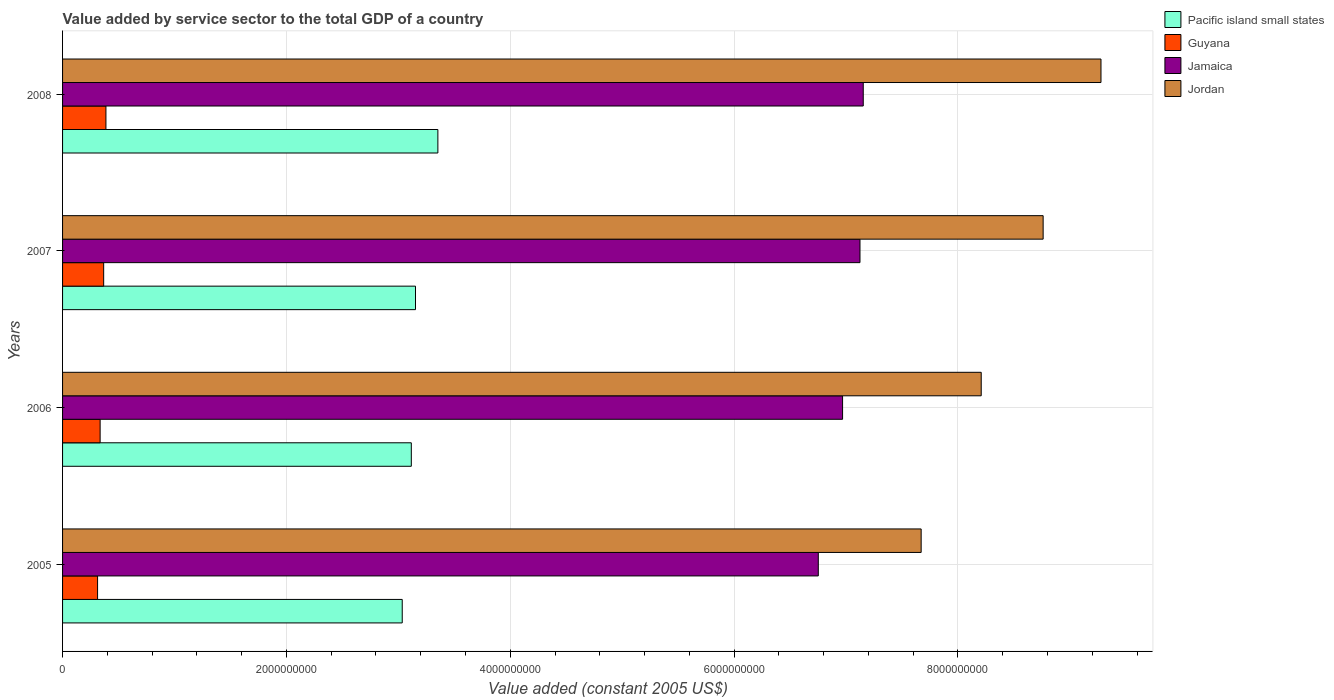How many different coloured bars are there?
Your answer should be compact. 4. How many bars are there on the 2nd tick from the top?
Ensure brevity in your answer.  4. What is the value added by service sector in Guyana in 2005?
Offer a very short reply. 3.13e+08. Across all years, what is the maximum value added by service sector in Jamaica?
Give a very brief answer. 7.15e+09. Across all years, what is the minimum value added by service sector in Pacific island small states?
Keep it short and to the point. 3.03e+09. What is the total value added by service sector in Pacific island small states in the graph?
Provide a succinct answer. 1.27e+1. What is the difference between the value added by service sector in Jamaica in 2006 and that in 2007?
Offer a very short reply. -1.55e+08. What is the difference between the value added by service sector in Jamaica in 2008 and the value added by service sector in Guyana in 2007?
Offer a very short reply. 6.79e+09. What is the average value added by service sector in Jamaica per year?
Your answer should be compact. 7.00e+09. In the year 2007, what is the difference between the value added by service sector in Jordan and value added by service sector in Jamaica?
Provide a succinct answer. 1.64e+09. What is the ratio of the value added by service sector in Pacific island small states in 2007 to that in 2008?
Your response must be concise. 0.94. What is the difference between the highest and the second highest value added by service sector in Jamaica?
Offer a terse response. 2.92e+07. What is the difference between the highest and the lowest value added by service sector in Jamaica?
Your answer should be very brief. 4.02e+08. What does the 1st bar from the top in 2007 represents?
Your answer should be compact. Jordan. What does the 2nd bar from the bottom in 2005 represents?
Make the answer very short. Guyana. How many bars are there?
Offer a very short reply. 16. How many years are there in the graph?
Provide a succinct answer. 4. Does the graph contain any zero values?
Make the answer very short. No. How many legend labels are there?
Ensure brevity in your answer.  4. How are the legend labels stacked?
Your answer should be compact. Vertical. What is the title of the graph?
Provide a short and direct response. Value added by service sector to the total GDP of a country. Does "Greece" appear as one of the legend labels in the graph?
Provide a short and direct response. No. What is the label or title of the X-axis?
Your answer should be compact. Value added (constant 2005 US$). What is the label or title of the Y-axis?
Ensure brevity in your answer.  Years. What is the Value added (constant 2005 US$) of Pacific island small states in 2005?
Make the answer very short. 3.03e+09. What is the Value added (constant 2005 US$) of Guyana in 2005?
Offer a very short reply. 3.13e+08. What is the Value added (constant 2005 US$) of Jamaica in 2005?
Provide a short and direct response. 6.75e+09. What is the Value added (constant 2005 US$) of Jordan in 2005?
Make the answer very short. 7.67e+09. What is the Value added (constant 2005 US$) of Pacific island small states in 2006?
Offer a very short reply. 3.12e+09. What is the Value added (constant 2005 US$) of Guyana in 2006?
Make the answer very short. 3.36e+08. What is the Value added (constant 2005 US$) of Jamaica in 2006?
Your answer should be very brief. 6.97e+09. What is the Value added (constant 2005 US$) in Jordan in 2006?
Offer a terse response. 8.21e+09. What is the Value added (constant 2005 US$) in Pacific island small states in 2007?
Ensure brevity in your answer.  3.15e+09. What is the Value added (constant 2005 US$) of Guyana in 2007?
Offer a terse response. 3.67e+08. What is the Value added (constant 2005 US$) in Jamaica in 2007?
Offer a terse response. 7.12e+09. What is the Value added (constant 2005 US$) in Jordan in 2007?
Your response must be concise. 8.76e+09. What is the Value added (constant 2005 US$) in Pacific island small states in 2008?
Provide a short and direct response. 3.35e+09. What is the Value added (constant 2005 US$) in Guyana in 2008?
Provide a short and direct response. 3.87e+08. What is the Value added (constant 2005 US$) in Jamaica in 2008?
Offer a very short reply. 7.15e+09. What is the Value added (constant 2005 US$) of Jordan in 2008?
Offer a very short reply. 9.28e+09. Across all years, what is the maximum Value added (constant 2005 US$) in Pacific island small states?
Your answer should be compact. 3.35e+09. Across all years, what is the maximum Value added (constant 2005 US$) of Guyana?
Ensure brevity in your answer.  3.87e+08. Across all years, what is the maximum Value added (constant 2005 US$) in Jamaica?
Offer a very short reply. 7.15e+09. Across all years, what is the maximum Value added (constant 2005 US$) of Jordan?
Make the answer very short. 9.28e+09. Across all years, what is the minimum Value added (constant 2005 US$) of Pacific island small states?
Your answer should be compact. 3.03e+09. Across all years, what is the minimum Value added (constant 2005 US$) of Guyana?
Provide a short and direct response. 3.13e+08. Across all years, what is the minimum Value added (constant 2005 US$) in Jamaica?
Offer a very short reply. 6.75e+09. Across all years, what is the minimum Value added (constant 2005 US$) in Jordan?
Give a very brief answer. 7.67e+09. What is the total Value added (constant 2005 US$) of Pacific island small states in the graph?
Your answer should be compact. 1.27e+1. What is the total Value added (constant 2005 US$) of Guyana in the graph?
Provide a succinct answer. 1.40e+09. What is the total Value added (constant 2005 US$) of Jamaica in the graph?
Ensure brevity in your answer.  2.80e+1. What is the total Value added (constant 2005 US$) in Jordan in the graph?
Provide a succinct answer. 3.39e+1. What is the difference between the Value added (constant 2005 US$) in Pacific island small states in 2005 and that in 2006?
Provide a short and direct response. -8.11e+07. What is the difference between the Value added (constant 2005 US$) of Guyana in 2005 and that in 2006?
Offer a very short reply. -2.28e+07. What is the difference between the Value added (constant 2005 US$) in Jamaica in 2005 and that in 2006?
Your answer should be compact. -2.17e+08. What is the difference between the Value added (constant 2005 US$) in Jordan in 2005 and that in 2006?
Offer a very short reply. -5.37e+08. What is the difference between the Value added (constant 2005 US$) in Pacific island small states in 2005 and that in 2007?
Offer a very short reply. -1.18e+08. What is the difference between the Value added (constant 2005 US$) of Guyana in 2005 and that in 2007?
Your answer should be compact. -5.45e+07. What is the difference between the Value added (constant 2005 US$) of Jamaica in 2005 and that in 2007?
Your answer should be very brief. -3.72e+08. What is the difference between the Value added (constant 2005 US$) in Jordan in 2005 and that in 2007?
Provide a short and direct response. -1.09e+09. What is the difference between the Value added (constant 2005 US$) in Pacific island small states in 2005 and that in 2008?
Keep it short and to the point. -3.18e+08. What is the difference between the Value added (constant 2005 US$) in Guyana in 2005 and that in 2008?
Provide a short and direct response. -7.47e+07. What is the difference between the Value added (constant 2005 US$) in Jamaica in 2005 and that in 2008?
Offer a terse response. -4.02e+08. What is the difference between the Value added (constant 2005 US$) of Jordan in 2005 and that in 2008?
Provide a succinct answer. -1.61e+09. What is the difference between the Value added (constant 2005 US$) of Pacific island small states in 2006 and that in 2007?
Keep it short and to the point. -3.74e+07. What is the difference between the Value added (constant 2005 US$) of Guyana in 2006 and that in 2007?
Offer a terse response. -3.16e+07. What is the difference between the Value added (constant 2005 US$) of Jamaica in 2006 and that in 2007?
Provide a succinct answer. -1.55e+08. What is the difference between the Value added (constant 2005 US$) in Jordan in 2006 and that in 2007?
Your answer should be compact. -5.53e+08. What is the difference between the Value added (constant 2005 US$) in Pacific island small states in 2006 and that in 2008?
Ensure brevity in your answer.  -2.37e+08. What is the difference between the Value added (constant 2005 US$) of Guyana in 2006 and that in 2008?
Offer a terse response. -5.18e+07. What is the difference between the Value added (constant 2005 US$) in Jamaica in 2006 and that in 2008?
Provide a short and direct response. -1.85e+08. What is the difference between the Value added (constant 2005 US$) in Jordan in 2006 and that in 2008?
Make the answer very short. -1.07e+09. What is the difference between the Value added (constant 2005 US$) of Pacific island small states in 2007 and that in 2008?
Provide a succinct answer. -2.00e+08. What is the difference between the Value added (constant 2005 US$) of Guyana in 2007 and that in 2008?
Offer a very short reply. -2.02e+07. What is the difference between the Value added (constant 2005 US$) of Jamaica in 2007 and that in 2008?
Ensure brevity in your answer.  -2.92e+07. What is the difference between the Value added (constant 2005 US$) in Jordan in 2007 and that in 2008?
Offer a very short reply. -5.17e+08. What is the difference between the Value added (constant 2005 US$) of Pacific island small states in 2005 and the Value added (constant 2005 US$) of Guyana in 2006?
Offer a very short reply. 2.70e+09. What is the difference between the Value added (constant 2005 US$) in Pacific island small states in 2005 and the Value added (constant 2005 US$) in Jamaica in 2006?
Offer a terse response. -3.93e+09. What is the difference between the Value added (constant 2005 US$) of Pacific island small states in 2005 and the Value added (constant 2005 US$) of Jordan in 2006?
Offer a very short reply. -5.17e+09. What is the difference between the Value added (constant 2005 US$) in Guyana in 2005 and the Value added (constant 2005 US$) in Jamaica in 2006?
Provide a succinct answer. -6.66e+09. What is the difference between the Value added (constant 2005 US$) in Guyana in 2005 and the Value added (constant 2005 US$) in Jordan in 2006?
Offer a terse response. -7.89e+09. What is the difference between the Value added (constant 2005 US$) in Jamaica in 2005 and the Value added (constant 2005 US$) in Jordan in 2006?
Give a very brief answer. -1.46e+09. What is the difference between the Value added (constant 2005 US$) of Pacific island small states in 2005 and the Value added (constant 2005 US$) of Guyana in 2007?
Give a very brief answer. 2.67e+09. What is the difference between the Value added (constant 2005 US$) of Pacific island small states in 2005 and the Value added (constant 2005 US$) of Jamaica in 2007?
Provide a succinct answer. -4.09e+09. What is the difference between the Value added (constant 2005 US$) of Pacific island small states in 2005 and the Value added (constant 2005 US$) of Jordan in 2007?
Ensure brevity in your answer.  -5.73e+09. What is the difference between the Value added (constant 2005 US$) in Guyana in 2005 and the Value added (constant 2005 US$) in Jamaica in 2007?
Make the answer very short. -6.81e+09. What is the difference between the Value added (constant 2005 US$) of Guyana in 2005 and the Value added (constant 2005 US$) of Jordan in 2007?
Keep it short and to the point. -8.45e+09. What is the difference between the Value added (constant 2005 US$) of Jamaica in 2005 and the Value added (constant 2005 US$) of Jordan in 2007?
Provide a short and direct response. -2.01e+09. What is the difference between the Value added (constant 2005 US$) of Pacific island small states in 2005 and the Value added (constant 2005 US$) of Guyana in 2008?
Make the answer very short. 2.65e+09. What is the difference between the Value added (constant 2005 US$) of Pacific island small states in 2005 and the Value added (constant 2005 US$) of Jamaica in 2008?
Offer a very short reply. -4.12e+09. What is the difference between the Value added (constant 2005 US$) in Pacific island small states in 2005 and the Value added (constant 2005 US$) in Jordan in 2008?
Your answer should be very brief. -6.24e+09. What is the difference between the Value added (constant 2005 US$) of Guyana in 2005 and the Value added (constant 2005 US$) of Jamaica in 2008?
Offer a terse response. -6.84e+09. What is the difference between the Value added (constant 2005 US$) of Guyana in 2005 and the Value added (constant 2005 US$) of Jordan in 2008?
Provide a succinct answer. -8.96e+09. What is the difference between the Value added (constant 2005 US$) of Jamaica in 2005 and the Value added (constant 2005 US$) of Jordan in 2008?
Keep it short and to the point. -2.53e+09. What is the difference between the Value added (constant 2005 US$) of Pacific island small states in 2006 and the Value added (constant 2005 US$) of Guyana in 2007?
Keep it short and to the point. 2.75e+09. What is the difference between the Value added (constant 2005 US$) of Pacific island small states in 2006 and the Value added (constant 2005 US$) of Jamaica in 2007?
Offer a very short reply. -4.01e+09. What is the difference between the Value added (constant 2005 US$) of Pacific island small states in 2006 and the Value added (constant 2005 US$) of Jordan in 2007?
Give a very brief answer. -5.65e+09. What is the difference between the Value added (constant 2005 US$) of Guyana in 2006 and the Value added (constant 2005 US$) of Jamaica in 2007?
Make the answer very short. -6.79e+09. What is the difference between the Value added (constant 2005 US$) of Guyana in 2006 and the Value added (constant 2005 US$) of Jordan in 2007?
Your response must be concise. -8.43e+09. What is the difference between the Value added (constant 2005 US$) in Jamaica in 2006 and the Value added (constant 2005 US$) in Jordan in 2007?
Offer a terse response. -1.79e+09. What is the difference between the Value added (constant 2005 US$) of Pacific island small states in 2006 and the Value added (constant 2005 US$) of Guyana in 2008?
Your answer should be very brief. 2.73e+09. What is the difference between the Value added (constant 2005 US$) in Pacific island small states in 2006 and the Value added (constant 2005 US$) in Jamaica in 2008?
Offer a terse response. -4.04e+09. What is the difference between the Value added (constant 2005 US$) in Pacific island small states in 2006 and the Value added (constant 2005 US$) in Jordan in 2008?
Offer a very short reply. -6.16e+09. What is the difference between the Value added (constant 2005 US$) of Guyana in 2006 and the Value added (constant 2005 US$) of Jamaica in 2008?
Offer a terse response. -6.82e+09. What is the difference between the Value added (constant 2005 US$) of Guyana in 2006 and the Value added (constant 2005 US$) of Jordan in 2008?
Give a very brief answer. -8.94e+09. What is the difference between the Value added (constant 2005 US$) in Jamaica in 2006 and the Value added (constant 2005 US$) in Jordan in 2008?
Keep it short and to the point. -2.31e+09. What is the difference between the Value added (constant 2005 US$) in Pacific island small states in 2007 and the Value added (constant 2005 US$) in Guyana in 2008?
Your answer should be very brief. 2.77e+09. What is the difference between the Value added (constant 2005 US$) of Pacific island small states in 2007 and the Value added (constant 2005 US$) of Jamaica in 2008?
Your answer should be very brief. -4.00e+09. What is the difference between the Value added (constant 2005 US$) in Pacific island small states in 2007 and the Value added (constant 2005 US$) in Jordan in 2008?
Offer a very short reply. -6.12e+09. What is the difference between the Value added (constant 2005 US$) of Guyana in 2007 and the Value added (constant 2005 US$) of Jamaica in 2008?
Offer a terse response. -6.79e+09. What is the difference between the Value added (constant 2005 US$) in Guyana in 2007 and the Value added (constant 2005 US$) in Jordan in 2008?
Provide a short and direct response. -8.91e+09. What is the difference between the Value added (constant 2005 US$) in Jamaica in 2007 and the Value added (constant 2005 US$) in Jordan in 2008?
Your answer should be compact. -2.15e+09. What is the average Value added (constant 2005 US$) in Pacific island small states per year?
Provide a short and direct response. 3.16e+09. What is the average Value added (constant 2005 US$) in Guyana per year?
Keep it short and to the point. 3.51e+08. What is the average Value added (constant 2005 US$) of Jamaica per year?
Your answer should be very brief. 7.00e+09. What is the average Value added (constant 2005 US$) of Jordan per year?
Provide a succinct answer. 8.48e+09. In the year 2005, what is the difference between the Value added (constant 2005 US$) in Pacific island small states and Value added (constant 2005 US$) in Guyana?
Provide a succinct answer. 2.72e+09. In the year 2005, what is the difference between the Value added (constant 2005 US$) in Pacific island small states and Value added (constant 2005 US$) in Jamaica?
Provide a succinct answer. -3.72e+09. In the year 2005, what is the difference between the Value added (constant 2005 US$) of Pacific island small states and Value added (constant 2005 US$) of Jordan?
Offer a terse response. -4.64e+09. In the year 2005, what is the difference between the Value added (constant 2005 US$) of Guyana and Value added (constant 2005 US$) of Jamaica?
Offer a terse response. -6.44e+09. In the year 2005, what is the difference between the Value added (constant 2005 US$) in Guyana and Value added (constant 2005 US$) in Jordan?
Provide a short and direct response. -7.36e+09. In the year 2005, what is the difference between the Value added (constant 2005 US$) of Jamaica and Value added (constant 2005 US$) of Jordan?
Give a very brief answer. -9.19e+08. In the year 2006, what is the difference between the Value added (constant 2005 US$) of Pacific island small states and Value added (constant 2005 US$) of Guyana?
Your answer should be very brief. 2.78e+09. In the year 2006, what is the difference between the Value added (constant 2005 US$) in Pacific island small states and Value added (constant 2005 US$) in Jamaica?
Your answer should be compact. -3.85e+09. In the year 2006, what is the difference between the Value added (constant 2005 US$) of Pacific island small states and Value added (constant 2005 US$) of Jordan?
Your response must be concise. -5.09e+09. In the year 2006, what is the difference between the Value added (constant 2005 US$) in Guyana and Value added (constant 2005 US$) in Jamaica?
Your answer should be compact. -6.63e+09. In the year 2006, what is the difference between the Value added (constant 2005 US$) of Guyana and Value added (constant 2005 US$) of Jordan?
Offer a terse response. -7.87e+09. In the year 2006, what is the difference between the Value added (constant 2005 US$) of Jamaica and Value added (constant 2005 US$) of Jordan?
Provide a short and direct response. -1.24e+09. In the year 2007, what is the difference between the Value added (constant 2005 US$) of Pacific island small states and Value added (constant 2005 US$) of Guyana?
Make the answer very short. 2.79e+09. In the year 2007, what is the difference between the Value added (constant 2005 US$) of Pacific island small states and Value added (constant 2005 US$) of Jamaica?
Ensure brevity in your answer.  -3.97e+09. In the year 2007, what is the difference between the Value added (constant 2005 US$) in Pacific island small states and Value added (constant 2005 US$) in Jordan?
Keep it short and to the point. -5.61e+09. In the year 2007, what is the difference between the Value added (constant 2005 US$) in Guyana and Value added (constant 2005 US$) in Jamaica?
Your answer should be very brief. -6.76e+09. In the year 2007, what is the difference between the Value added (constant 2005 US$) in Guyana and Value added (constant 2005 US$) in Jordan?
Offer a terse response. -8.39e+09. In the year 2007, what is the difference between the Value added (constant 2005 US$) in Jamaica and Value added (constant 2005 US$) in Jordan?
Your answer should be very brief. -1.64e+09. In the year 2008, what is the difference between the Value added (constant 2005 US$) of Pacific island small states and Value added (constant 2005 US$) of Guyana?
Your answer should be very brief. 2.97e+09. In the year 2008, what is the difference between the Value added (constant 2005 US$) of Pacific island small states and Value added (constant 2005 US$) of Jamaica?
Your response must be concise. -3.80e+09. In the year 2008, what is the difference between the Value added (constant 2005 US$) of Pacific island small states and Value added (constant 2005 US$) of Jordan?
Provide a succinct answer. -5.92e+09. In the year 2008, what is the difference between the Value added (constant 2005 US$) in Guyana and Value added (constant 2005 US$) in Jamaica?
Ensure brevity in your answer.  -6.77e+09. In the year 2008, what is the difference between the Value added (constant 2005 US$) of Guyana and Value added (constant 2005 US$) of Jordan?
Give a very brief answer. -8.89e+09. In the year 2008, what is the difference between the Value added (constant 2005 US$) in Jamaica and Value added (constant 2005 US$) in Jordan?
Offer a terse response. -2.12e+09. What is the ratio of the Value added (constant 2005 US$) in Guyana in 2005 to that in 2006?
Ensure brevity in your answer.  0.93. What is the ratio of the Value added (constant 2005 US$) in Jamaica in 2005 to that in 2006?
Offer a terse response. 0.97. What is the ratio of the Value added (constant 2005 US$) of Jordan in 2005 to that in 2006?
Your response must be concise. 0.93. What is the ratio of the Value added (constant 2005 US$) of Pacific island small states in 2005 to that in 2007?
Your answer should be compact. 0.96. What is the ratio of the Value added (constant 2005 US$) of Guyana in 2005 to that in 2007?
Your response must be concise. 0.85. What is the ratio of the Value added (constant 2005 US$) of Jamaica in 2005 to that in 2007?
Provide a short and direct response. 0.95. What is the ratio of the Value added (constant 2005 US$) in Jordan in 2005 to that in 2007?
Ensure brevity in your answer.  0.88. What is the ratio of the Value added (constant 2005 US$) in Pacific island small states in 2005 to that in 2008?
Provide a short and direct response. 0.91. What is the ratio of the Value added (constant 2005 US$) of Guyana in 2005 to that in 2008?
Make the answer very short. 0.81. What is the ratio of the Value added (constant 2005 US$) in Jamaica in 2005 to that in 2008?
Offer a terse response. 0.94. What is the ratio of the Value added (constant 2005 US$) of Jordan in 2005 to that in 2008?
Offer a very short reply. 0.83. What is the ratio of the Value added (constant 2005 US$) of Pacific island small states in 2006 to that in 2007?
Make the answer very short. 0.99. What is the ratio of the Value added (constant 2005 US$) of Guyana in 2006 to that in 2007?
Your response must be concise. 0.91. What is the ratio of the Value added (constant 2005 US$) of Jamaica in 2006 to that in 2007?
Provide a short and direct response. 0.98. What is the ratio of the Value added (constant 2005 US$) in Jordan in 2006 to that in 2007?
Keep it short and to the point. 0.94. What is the ratio of the Value added (constant 2005 US$) in Pacific island small states in 2006 to that in 2008?
Provide a short and direct response. 0.93. What is the ratio of the Value added (constant 2005 US$) in Guyana in 2006 to that in 2008?
Keep it short and to the point. 0.87. What is the ratio of the Value added (constant 2005 US$) of Jamaica in 2006 to that in 2008?
Offer a very short reply. 0.97. What is the ratio of the Value added (constant 2005 US$) in Jordan in 2006 to that in 2008?
Your response must be concise. 0.88. What is the ratio of the Value added (constant 2005 US$) of Pacific island small states in 2007 to that in 2008?
Your answer should be compact. 0.94. What is the ratio of the Value added (constant 2005 US$) of Guyana in 2007 to that in 2008?
Offer a very short reply. 0.95. What is the ratio of the Value added (constant 2005 US$) of Jordan in 2007 to that in 2008?
Provide a short and direct response. 0.94. What is the difference between the highest and the second highest Value added (constant 2005 US$) of Pacific island small states?
Your response must be concise. 2.00e+08. What is the difference between the highest and the second highest Value added (constant 2005 US$) of Guyana?
Ensure brevity in your answer.  2.02e+07. What is the difference between the highest and the second highest Value added (constant 2005 US$) in Jamaica?
Provide a short and direct response. 2.92e+07. What is the difference between the highest and the second highest Value added (constant 2005 US$) of Jordan?
Your response must be concise. 5.17e+08. What is the difference between the highest and the lowest Value added (constant 2005 US$) in Pacific island small states?
Keep it short and to the point. 3.18e+08. What is the difference between the highest and the lowest Value added (constant 2005 US$) in Guyana?
Provide a succinct answer. 7.47e+07. What is the difference between the highest and the lowest Value added (constant 2005 US$) in Jamaica?
Make the answer very short. 4.02e+08. What is the difference between the highest and the lowest Value added (constant 2005 US$) in Jordan?
Provide a short and direct response. 1.61e+09. 